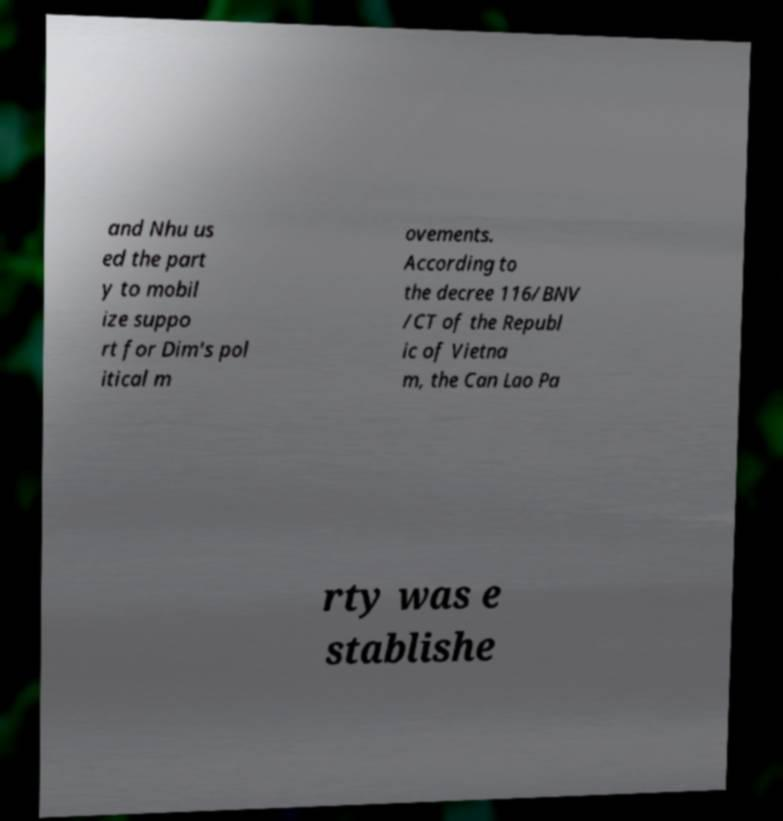Please identify and transcribe the text found in this image. and Nhu us ed the part y to mobil ize suppo rt for Dim's pol itical m ovements. According to the decree 116/BNV /CT of the Republ ic of Vietna m, the Can Lao Pa rty was e stablishe 